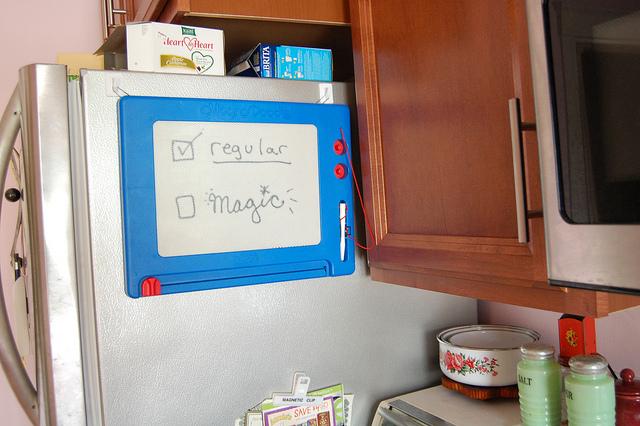What's on the fridge?
Write a very short answer. Magic board. What word doesn't have a check mark beside it?
Give a very brief answer. Magic. What word has a check mark beside it?
Keep it brief. Regular. What color are the salt and pepper shakers?
Quick response, please. Green. 